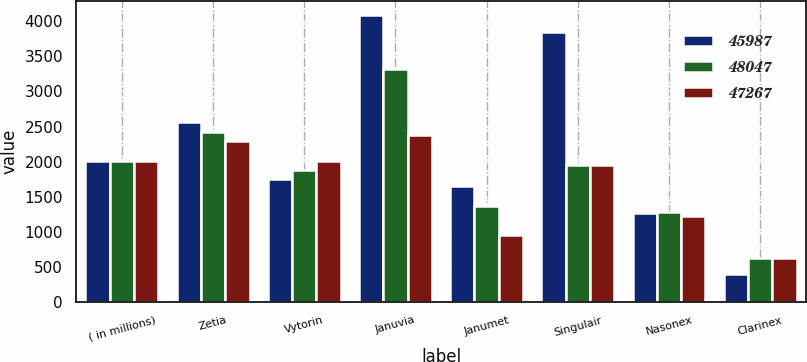<chart> <loc_0><loc_0><loc_500><loc_500><stacked_bar_chart><ecel><fcel>( in millions)<fcel>Zetia<fcel>Vytorin<fcel>Januvia<fcel>Janumet<fcel>Singulair<fcel>Nasonex<fcel>Clarinex<nl><fcel>45987<fcel>2012<fcel>2567<fcel>1747<fcel>4086<fcel>1659<fcel>3853<fcel>1268<fcel>393<nl><fcel>48047<fcel>2011<fcel>2428<fcel>1882<fcel>3324<fcel>1363<fcel>1946<fcel>1286<fcel>621<nl><fcel>47267<fcel>2010<fcel>2297<fcel>2014<fcel>2385<fcel>954<fcel>1946<fcel>1219<fcel>623<nl></chart> 